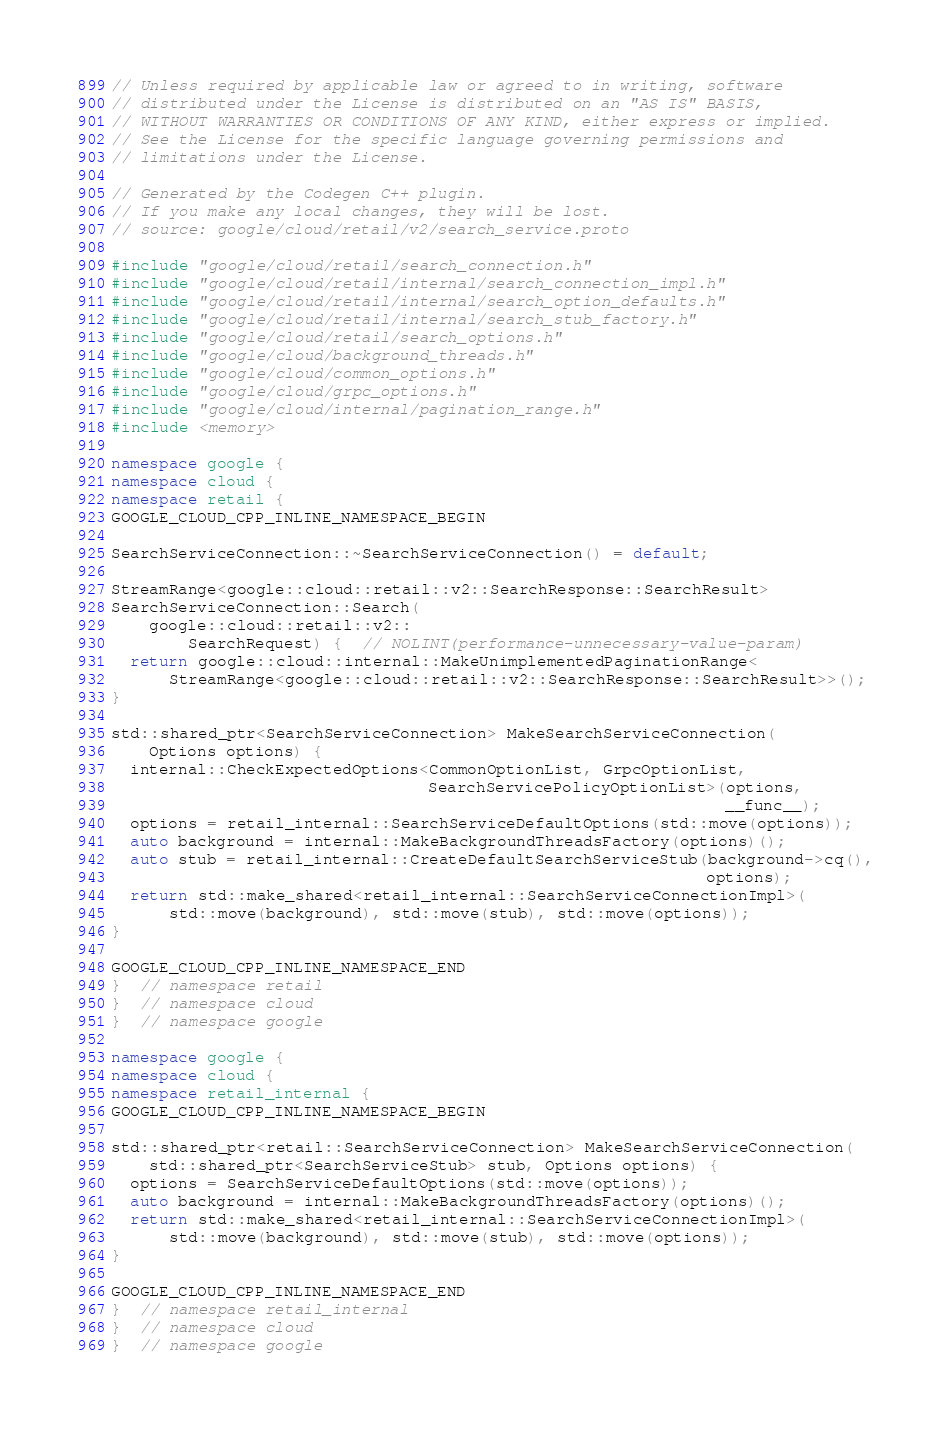Convert code to text. <code><loc_0><loc_0><loc_500><loc_500><_C++_>// Unless required by applicable law or agreed to in writing, software
// distributed under the License is distributed on an "AS IS" BASIS,
// WITHOUT WARRANTIES OR CONDITIONS OF ANY KIND, either express or implied.
// See the License for the specific language governing permissions and
// limitations under the License.

// Generated by the Codegen C++ plugin.
// If you make any local changes, they will be lost.
// source: google/cloud/retail/v2/search_service.proto

#include "google/cloud/retail/search_connection.h"
#include "google/cloud/retail/internal/search_connection_impl.h"
#include "google/cloud/retail/internal/search_option_defaults.h"
#include "google/cloud/retail/internal/search_stub_factory.h"
#include "google/cloud/retail/search_options.h"
#include "google/cloud/background_threads.h"
#include "google/cloud/common_options.h"
#include "google/cloud/grpc_options.h"
#include "google/cloud/internal/pagination_range.h"
#include <memory>

namespace google {
namespace cloud {
namespace retail {
GOOGLE_CLOUD_CPP_INLINE_NAMESPACE_BEGIN

SearchServiceConnection::~SearchServiceConnection() = default;

StreamRange<google::cloud::retail::v2::SearchResponse::SearchResult>
SearchServiceConnection::Search(
    google::cloud::retail::v2::
        SearchRequest) {  // NOLINT(performance-unnecessary-value-param)
  return google::cloud::internal::MakeUnimplementedPaginationRange<
      StreamRange<google::cloud::retail::v2::SearchResponse::SearchResult>>();
}

std::shared_ptr<SearchServiceConnection> MakeSearchServiceConnection(
    Options options) {
  internal::CheckExpectedOptions<CommonOptionList, GrpcOptionList,
                                 SearchServicePolicyOptionList>(options,
                                                                __func__);
  options = retail_internal::SearchServiceDefaultOptions(std::move(options));
  auto background = internal::MakeBackgroundThreadsFactory(options)();
  auto stub = retail_internal::CreateDefaultSearchServiceStub(background->cq(),
                                                              options);
  return std::make_shared<retail_internal::SearchServiceConnectionImpl>(
      std::move(background), std::move(stub), std::move(options));
}

GOOGLE_CLOUD_CPP_INLINE_NAMESPACE_END
}  // namespace retail
}  // namespace cloud
}  // namespace google

namespace google {
namespace cloud {
namespace retail_internal {
GOOGLE_CLOUD_CPP_INLINE_NAMESPACE_BEGIN

std::shared_ptr<retail::SearchServiceConnection> MakeSearchServiceConnection(
    std::shared_ptr<SearchServiceStub> stub, Options options) {
  options = SearchServiceDefaultOptions(std::move(options));
  auto background = internal::MakeBackgroundThreadsFactory(options)();
  return std::make_shared<retail_internal::SearchServiceConnectionImpl>(
      std::move(background), std::move(stub), std::move(options));
}

GOOGLE_CLOUD_CPP_INLINE_NAMESPACE_END
}  // namespace retail_internal
}  // namespace cloud
}  // namespace google
</code> 